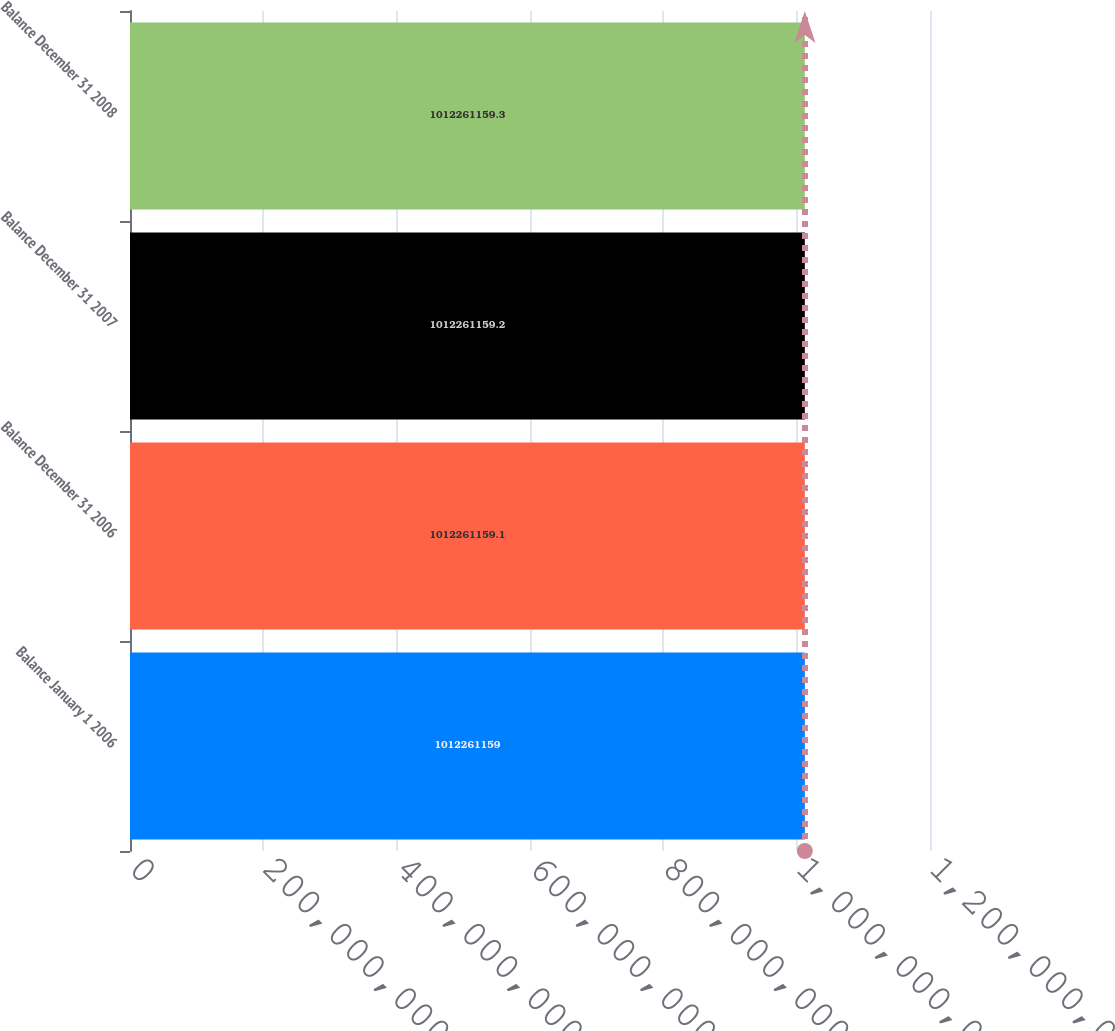Convert chart. <chart><loc_0><loc_0><loc_500><loc_500><bar_chart><fcel>Balance January 1 2006<fcel>Balance December 31 2006<fcel>Balance December 31 2007<fcel>Balance December 31 2008<nl><fcel>1.01226e+09<fcel>1.01226e+09<fcel>1.01226e+09<fcel>1.01226e+09<nl></chart> 